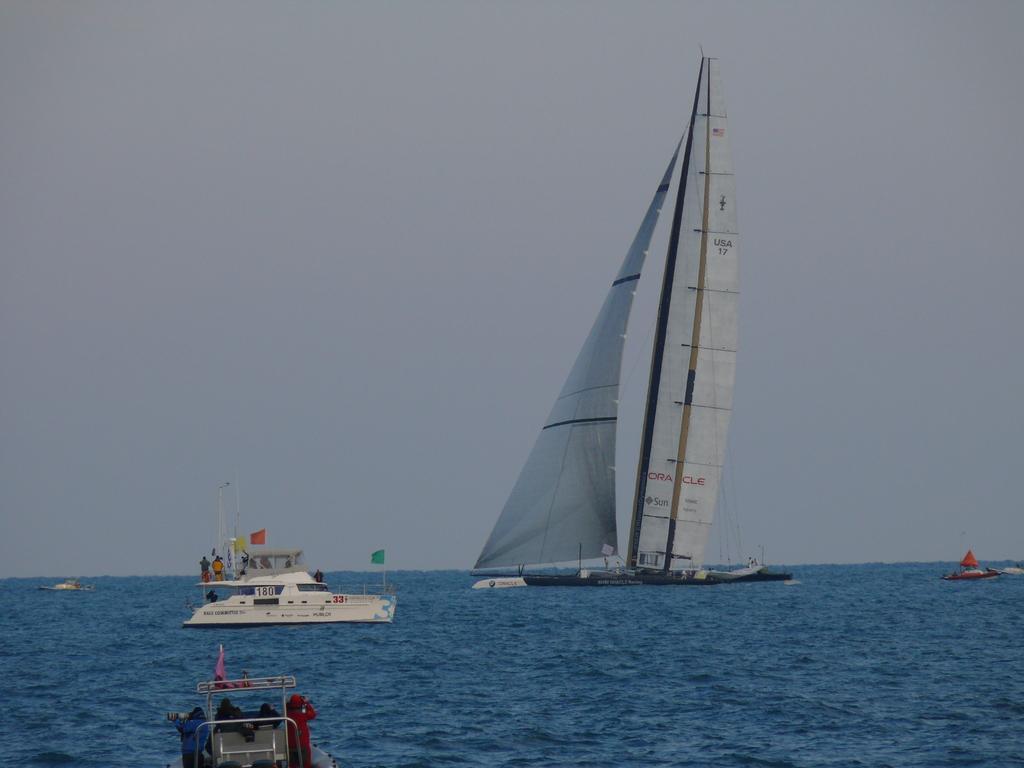Could you give a brief overview of what you see in this image? In this image we can see ships on the water and there are few persons and flagpoles on the ships. In the background we can see the sky. 